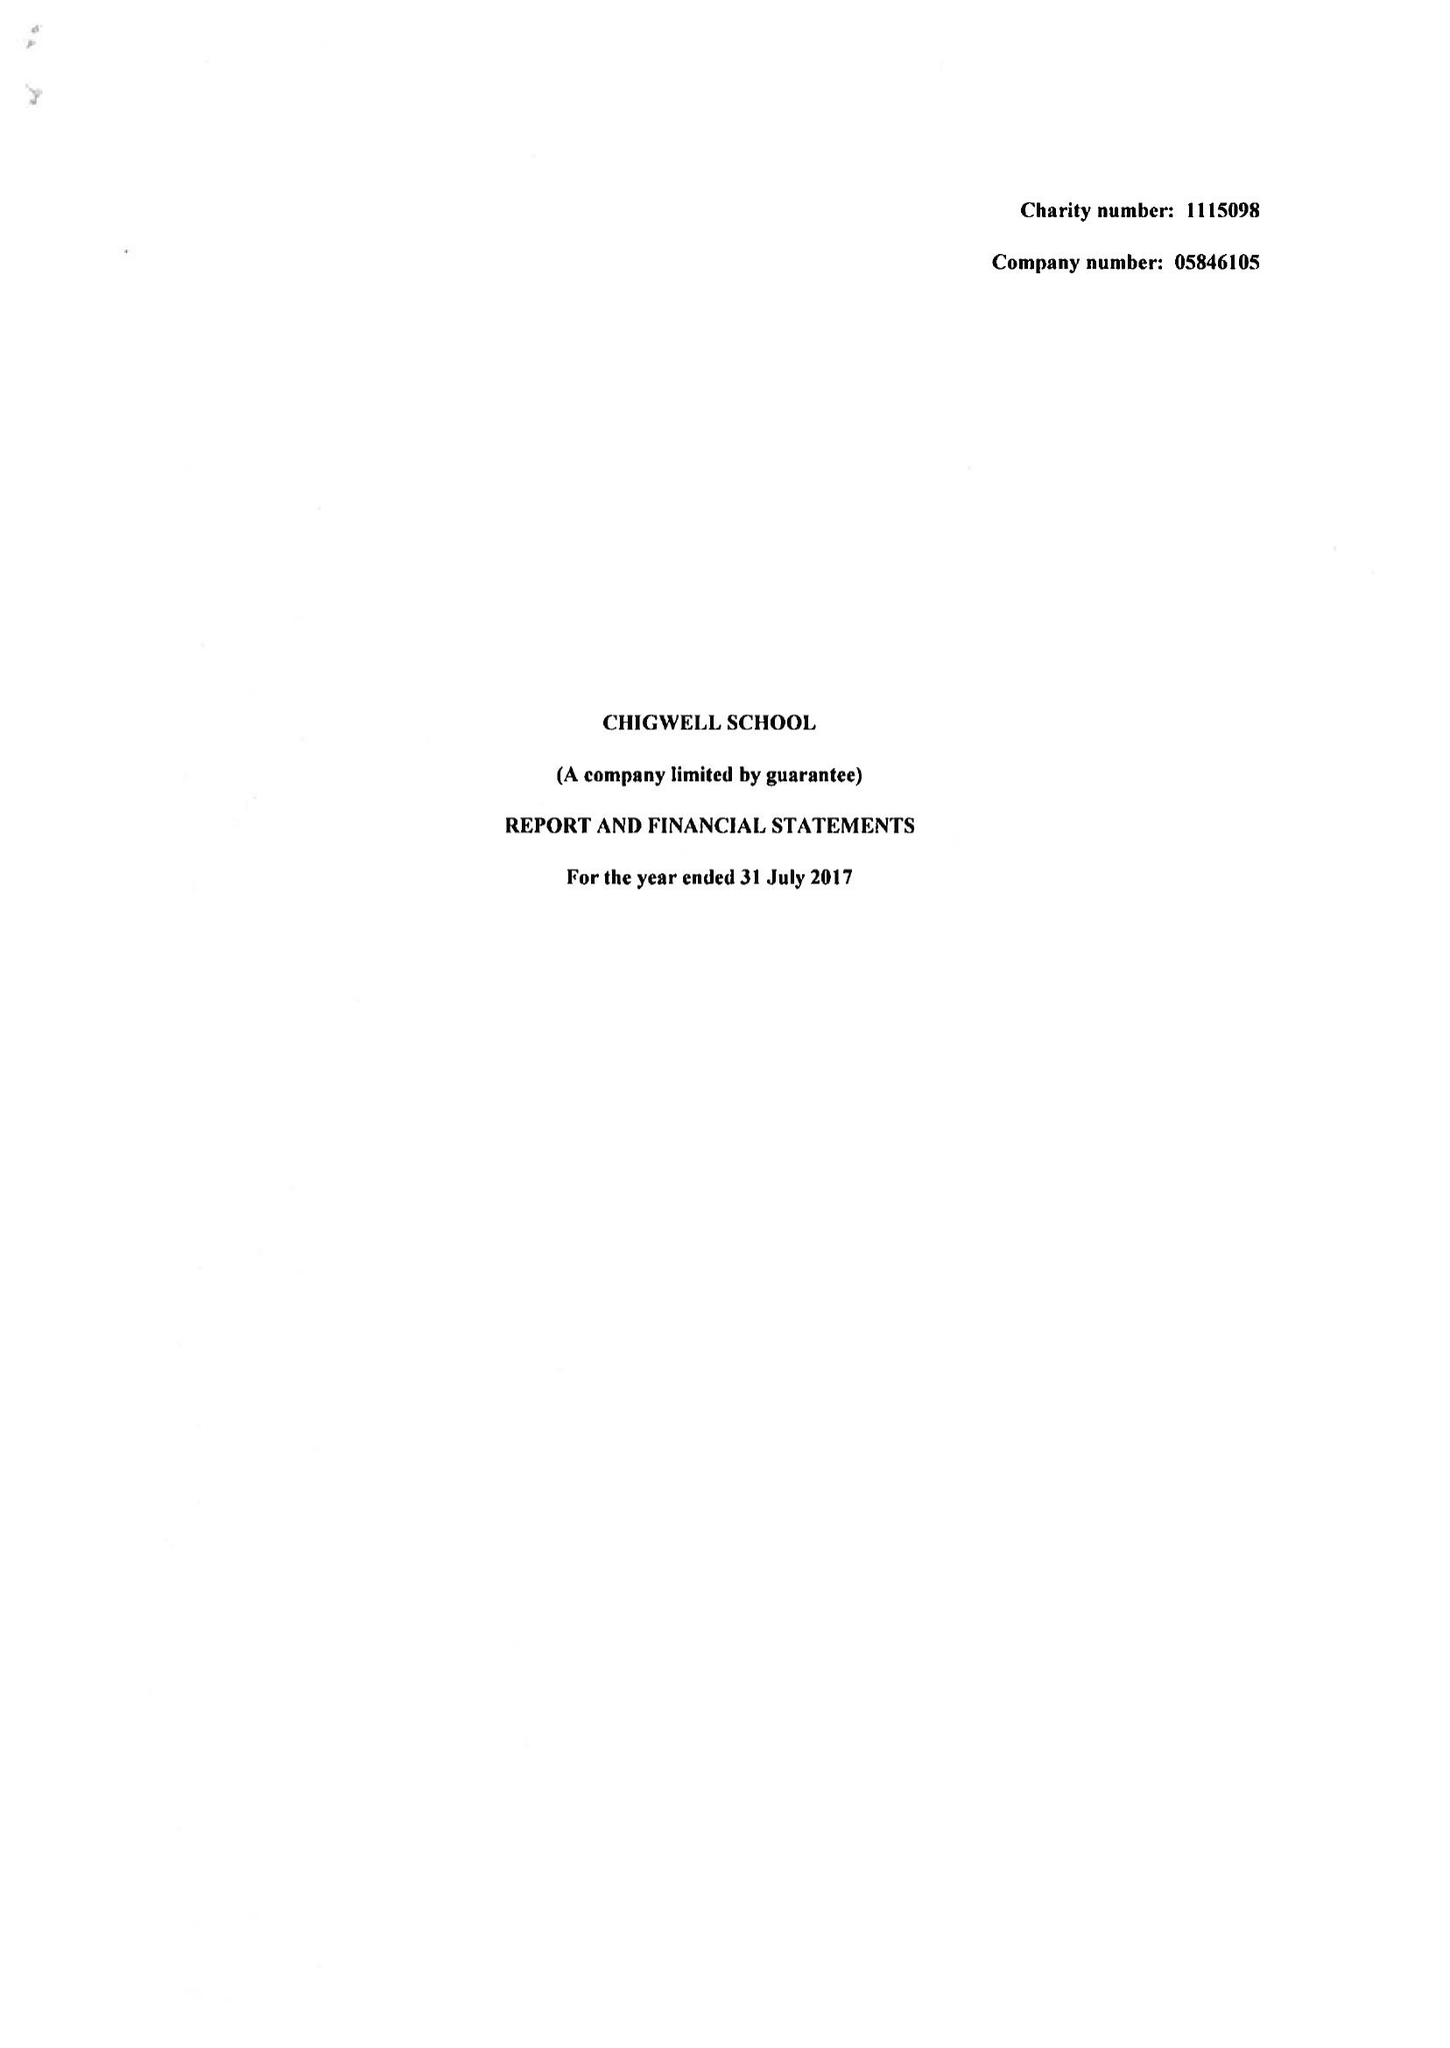What is the value for the address__street_line?
Answer the question using a single word or phrase. HIGH ROAD 